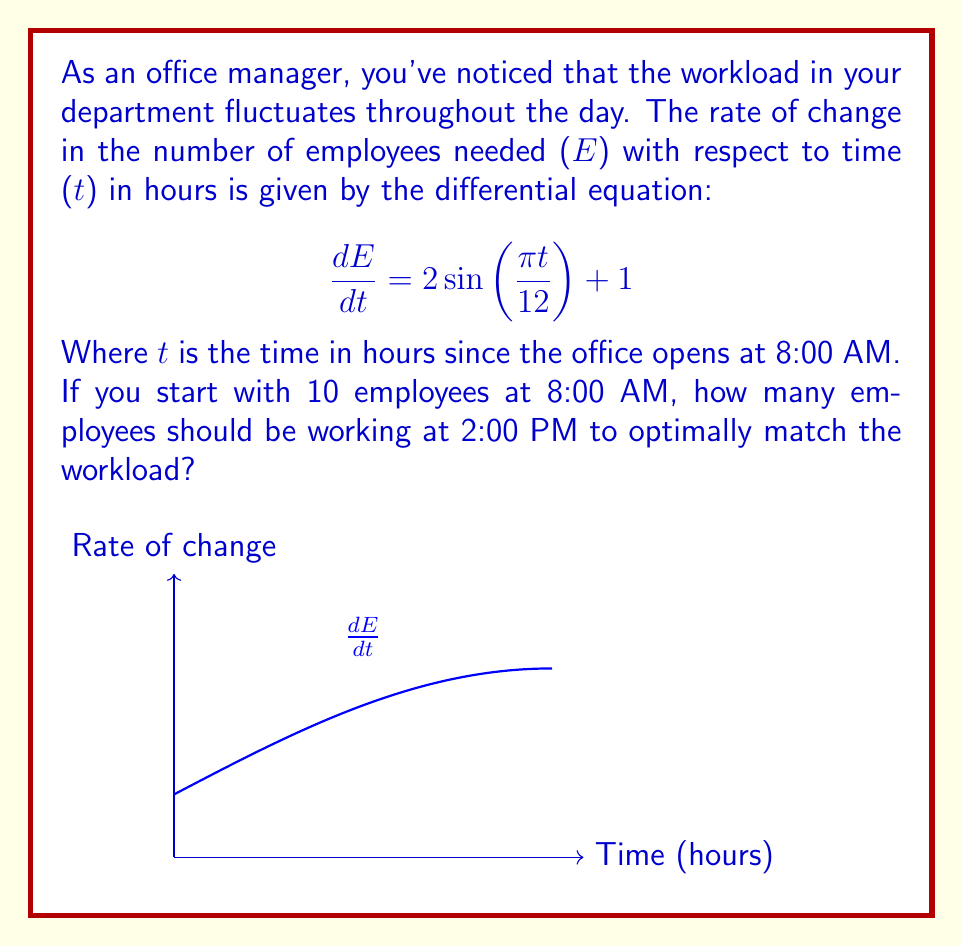Solve this math problem. Let's approach this step-by-step:

1) We need to solve the differential equation:
   $$\frac{dE}{dt} = 2\sin(\frac{\pi t}{12}) + 1$$

2) To solve this, we integrate both sides:
   $$E = \int (2\sin(\frac{\pi t}{12}) + 1) dt$$

3) Integrating:
   $$E = -\frac{24}{\pi}\cos(\frac{\pi t}{12}) + t + C$$

4) We know that at t=0 (8:00 AM), E=10. Let's use this to find C:
   $$10 = -\frac{24}{\pi}\cos(0) + 0 + C$$
   $$10 = -\frac{24}{\pi} + C$$
   $$C = 10 + \frac{24}{\pi}$$

5) So our complete solution is:
   $$E = -\frac{24}{\pi}\cos(\frac{\pi t}{12}) + t + 10 + \frac{24}{\pi}$$

6) Now, we need to find E at 2:00 PM, which is 6 hours after 8:00 AM. So t=6:
   $$E(6) = -\frac{24}{\pi}\cos(\frac{\pi \cdot 6}{12}) + 6 + 10 + \frac{24}{\pi}$$

7) Simplifying:
   $$E(6) = -\frac{24}{\pi}\cos(\frac{\pi}{2}) + 16 + \frac{24}{\pi}$$
   $$E(6) = 0 + 16 + \frac{24}{\pi} \approx 23.64$$

8) Since we can't have fractional employees, we round to the nearest whole number.
Answer: 24 employees 